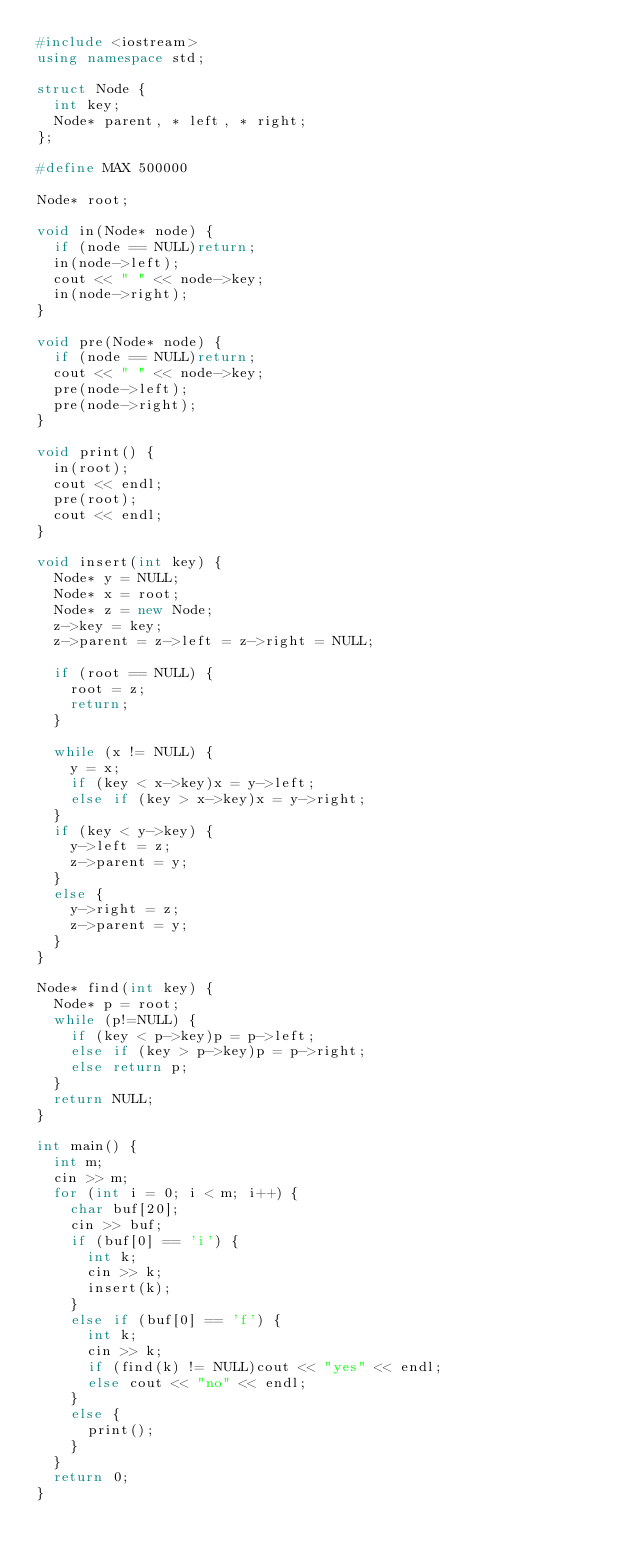Convert code to text. <code><loc_0><loc_0><loc_500><loc_500><_C++_>#include <iostream>
using namespace std;

struct Node {
	int key;
	Node* parent, * left, * right;
};

#define MAX 500000

Node* root;

void in(Node* node) {
	if (node == NULL)return;
	in(node->left);
	cout << " " << node->key;
	in(node->right);
}

void pre(Node* node) {
	if (node == NULL)return;
	cout << " " << node->key;
	pre(node->left);
	pre(node->right);
}

void print() {
	in(root);
	cout << endl;
	pre(root);
	cout << endl;
}

void insert(int key) {
	Node* y = NULL;
	Node* x = root;
	Node* z = new Node;
	z->key = key;
	z->parent = z->left = z->right = NULL;

	if (root == NULL) {
		root = z;
		return;
	}

	while (x != NULL) {
		y = x;
		if (key < x->key)x = y->left;
		else if (key > x->key)x = y->right;
	}
	if (key < y->key) {
		y->left = z;
		z->parent = y;
	}
	else {
		y->right = z;
		z->parent = y;
	}
}

Node* find(int key) {
	Node* p = root;
	while (p!=NULL) {
		if (key < p->key)p = p->left;
		else if (key > p->key)p = p->right;
		else return p;
	}
	return NULL;
}

int main() {
	int m;
	cin >> m;
	for (int i = 0; i < m; i++) {
		char buf[20];
		cin >> buf;
		if (buf[0] == 'i') {
			int k;
			cin >> k;
			insert(k);
		}
		else if (buf[0] == 'f') {
			int k;
			cin >> k;
			if (find(k) != NULL)cout << "yes" << endl;
			else cout << "no" << endl;
		}
		else {
			print();
		}
	}
	return 0;
}
</code> 